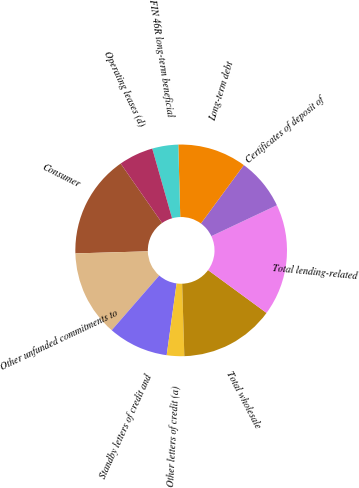<chart> <loc_0><loc_0><loc_500><loc_500><pie_chart><fcel>Consumer<fcel>Other unfunded commitments to<fcel>Standby letters of credit and<fcel>Other letters of credit (a)<fcel>Total wholesale<fcel>Total lending-related<fcel>Certificates of deposit of<fcel>Long-term debt<fcel>FIN 46R long-term beneficial<fcel>Operating leases (d)<nl><fcel>15.77%<fcel>13.15%<fcel>9.21%<fcel>2.66%<fcel>14.46%<fcel>17.08%<fcel>7.9%<fcel>10.52%<fcel>3.97%<fcel>5.28%<nl></chart> 